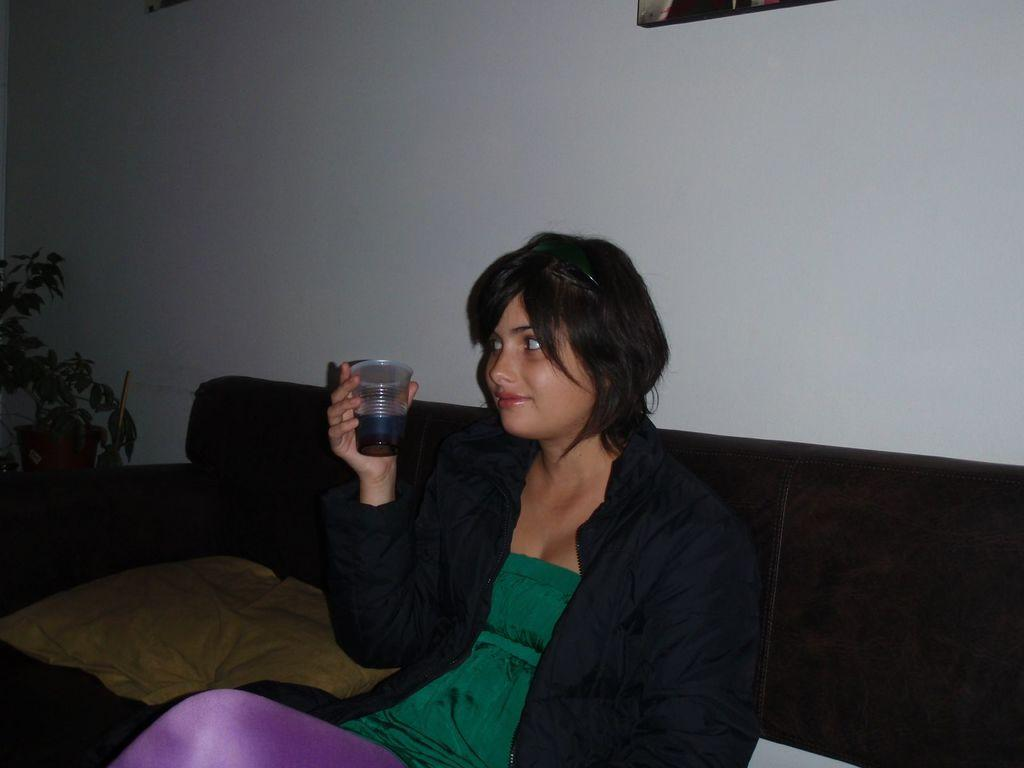Who is present in the image? There is a woman in the image. What is the woman holding in the image? The woman is holding a glass. What is located next to the woman in the image? There is a plant beside the woman. What is inside the glass that the woman is holding? The glass contains a drink. What type of meat is being produced by the plant in the image? There is no meat being produced by the plant in the image, as plants typically do not produce meat. 